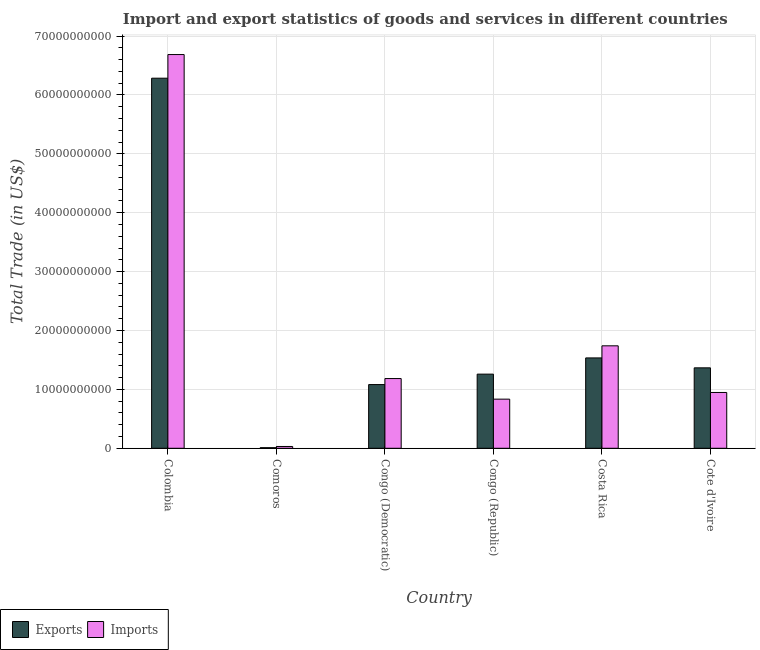How many groups of bars are there?
Offer a very short reply. 6. Are the number of bars per tick equal to the number of legend labels?
Provide a short and direct response. Yes. Are the number of bars on each tick of the X-axis equal?
Offer a very short reply. Yes. How many bars are there on the 6th tick from the right?
Your response must be concise. 2. What is the label of the 6th group of bars from the left?
Provide a succinct answer. Cote d'Ivoire. What is the imports of goods and services in Congo (Democratic)?
Your answer should be very brief. 1.18e+1. Across all countries, what is the maximum imports of goods and services?
Keep it short and to the point. 6.69e+1. Across all countries, what is the minimum imports of goods and services?
Your answer should be compact. 3.06e+08. In which country was the imports of goods and services minimum?
Your answer should be compact. Comoros. What is the total export of goods and services in the graph?
Keep it short and to the point. 1.15e+11. What is the difference between the imports of goods and services in Congo (Republic) and that in Cote d'Ivoire?
Your answer should be compact. -1.13e+09. What is the difference between the imports of goods and services in Congo (Republic) and the export of goods and services in Costa Rica?
Provide a short and direct response. -7.00e+09. What is the average export of goods and services per country?
Give a very brief answer. 1.92e+1. What is the difference between the export of goods and services and imports of goods and services in Cote d'Ivoire?
Keep it short and to the point. 4.18e+09. What is the ratio of the export of goods and services in Congo (Democratic) to that in Costa Rica?
Ensure brevity in your answer.  0.7. What is the difference between the highest and the second highest imports of goods and services?
Provide a succinct answer. 4.95e+1. What is the difference between the highest and the lowest imports of goods and services?
Offer a terse response. 6.66e+1. In how many countries, is the export of goods and services greater than the average export of goods and services taken over all countries?
Your answer should be very brief. 1. Is the sum of the export of goods and services in Congo (Republic) and Costa Rica greater than the maximum imports of goods and services across all countries?
Offer a terse response. No. What does the 2nd bar from the left in Cote d'Ivoire represents?
Provide a short and direct response. Imports. What does the 1st bar from the right in Congo (Republic) represents?
Give a very brief answer. Imports. How many bars are there?
Provide a short and direct response. 12. Are all the bars in the graph horizontal?
Ensure brevity in your answer.  No. How many countries are there in the graph?
Offer a terse response. 6. What is the difference between two consecutive major ticks on the Y-axis?
Offer a very short reply. 1.00e+1. What is the title of the graph?
Make the answer very short. Import and export statistics of goods and services in different countries. What is the label or title of the Y-axis?
Keep it short and to the point. Total Trade (in US$). What is the Total Trade (in US$) in Exports in Colombia?
Your answer should be compact. 6.28e+1. What is the Total Trade (in US$) in Imports in Colombia?
Your answer should be very brief. 6.69e+1. What is the Total Trade (in US$) in Exports in Comoros?
Your answer should be very brief. 9.90e+07. What is the Total Trade (in US$) of Imports in Comoros?
Ensure brevity in your answer.  3.06e+08. What is the Total Trade (in US$) in Exports in Congo (Democratic)?
Your response must be concise. 1.08e+1. What is the Total Trade (in US$) in Imports in Congo (Democratic)?
Provide a succinct answer. 1.18e+1. What is the Total Trade (in US$) in Exports in Congo (Republic)?
Your response must be concise. 1.26e+1. What is the Total Trade (in US$) in Imports in Congo (Republic)?
Provide a succinct answer. 8.34e+09. What is the Total Trade (in US$) in Exports in Costa Rica?
Offer a very short reply. 1.53e+1. What is the Total Trade (in US$) of Imports in Costa Rica?
Offer a terse response. 1.74e+1. What is the Total Trade (in US$) in Exports in Cote d'Ivoire?
Provide a succinct answer. 1.37e+1. What is the Total Trade (in US$) of Imports in Cote d'Ivoire?
Make the answer very short. 9.48e+09. Across all countries, what is the maximum Total Trade (in US$) in Exports?
Your answer should be compact. 6.28e+1. Across all countries, what is the maximum Total Trade (in US$) in Imports?
Provide a succinct answer. 6.69e+1. Across all countries, what is the minimum Total Trade (in US$) of Exports?
Offer a very short reply. 9.90e+07. Across all countries, what is the minimum Total Trade (in US$) in Imports?
Keep it short and to the point. 3.06e+08. What is the total Total Trade (in US$) of Exports in the graph?
Provide a succinct answer. 1.15e+11. What is the total Total Trade (in US$) in Imports in the graph?
Offer a very short reply. 1.14e+11. What is the difference between the Total Trade (in US$) in Exports in Colombia and that in Comoros?
Give a very brief answer. 6.27e+1. What is the difference between the Total Trade (in US$) in Imports in Colombia and that in Comoros?
Ensure brevity in your answer.  6.66e+1. What is the difference between the Total Trade (in US$) of Exports in Colombia and that in Congo (Democratic)?
Offer a very short reply. 5.20e+1. What is the difference between the Total Trade (in US$) of Imports in Colombia and that in Congo (Democratic)?
Offer a terse response. 5.50e+1. What is the difference between the Total Trade (in US$) in Exports in Colombia and that in Congo (Republic)?
Your response must be concise. 5.03e+1. What is the difference between the Total Trade (in US$) of Imports in Colombia and that in Congo (Republic)?
Provide a succinct answer. 5.85e+1. What is the difference between the Total Trade (in US$) in Exports in Colombia and that in Costa Rica?
Your answer should be very brief. 4.75e+1. What is the difference between the Total Trade (in US$) in Imports in Colombia and that in Costa Rica?
Provide a succinct answer. 4.95e+1. What is the difference between the Total Trade (in US$) of Exports in Colombia and that in Cote d'Ivoire?
Offer a very short reply. 4.92e+1. What is the difference between the Total Trade (in US$) of Imports in Colombia and that in Cote d'Ivoire?
Ensure brevity in your answer.  5.74e+1. What is the difference between the Total Trade (in US$) of Exports in Comoros and that in Congo (Democratic)?
Your response must be concise. -1.07e+1. What is the difference between the Total Trade (in US$) in Imports in Comoros and that in Congo (Democratic)?
Ensure brevity in your answer.  -1.15e+1. What is the difference between the Total Trade (in US$) of Exports in Comoros and that in Congo (Republic)?
Your response must be concise. -1.25e+1. What is the difference between the Total Trade (in US$) in Imports in Comoros and that in Congo (Republic)?
Your response must be concise. -8.04e+09. What is the difference between the Total Trade (in US$) of Exports in Comoros and that in Costa Rica?
Provide a succinct answer. -1.52e+1. What is the difference between the Total Trade (in US$) in Imports in Comoros and that in Costa Rica?
Make the answer very short. -1.71e+1. What is the difference between the Total Trade (in US$) in Exports in Comoros and that in Cote d'Ivoire?
Your response must be concise. -1.36e+1. What is the difference between the Total Trade (in US$) in Imports in Comoros and that in Cote d'Ivoire?
Your response must be concise. -9.17e+09. What is the difference between the Total Trade (in US$) in Exports in Congo (Democratic) and that in Congo (Republic)?
Keep it short and to the point. -1.77e+09. What is the difference between the Total Trade (in US$) of Imports in Congo (Democratic) and that in Congo (Republic)?
Make the answer very short. 3.50e+09. What is the difference between the Total Trade (in US$) of Exports in Congo (Democratic) and that in Costa Rica?
Provide a short and direct response. -4.53e+09. What is the difference between the Total Trade (in US$) of Imports in Congo (Democratic) and that in Costa Rica?
Give a very brief answer. -5.56e+09. What is the difference between the Total Trade (in US$) of Exports in Congo (Democratic) and that in Cote d'Ivoire?
Your answer should be compact. -2.84e+09. What is the difference between the Total Trade (in US$) in Imports in Congo (Democratic) and that in Cote d'Ivoire?
Offer a very short reply. 2.36e+09. What is the difference between the Total Trade (in US$) in Exports in Congo (Republic) and that in Costa Rica?
Ensure brevity in your answer.  -2.75e+09. What is the difference between the Total Trade (in US$) of Imports in Congo (Republic) and that in Costa Rica?
Ensure brevity in your answer.  -9.06e+09. What is the difference between the Total Trade (in US$) of Exports in Congo (Republic) and that in Cote d'Ivoire?
Offer a very short reply. -1.07e+09. What is the difference between the Total Trade (in US$) of Imports in Congo (Republic) and that in Cote d'Ivoire?
Give a very brief answer. -1.13e+09. What is the difference between the Total Trade (in US$) in Exports in Costa Rica and that in Cote d'Ivoire?
Offer a very short reply. 1.68e+09. What is the difference between the Total Trade (in US$) of Imports in Costa Rica and that in Cote d'Ivoire?
Give a very brief answer. 7.92e+09. What is the difference between the Total Trade (in US$) in Exports in Colombia and the Total Trade (in US$) in Imports in Comoros?
Provide a succinct answer. 6.25e+1. What is the difference between the Total Trade (in US$) in Exports in Colombia and the Total Trade (in US$) in Imports in Congo (Democratic)?
Give a very brief answer. 5.10e+1. What is the difference between the Total Trade (in US$) in Exports in Colombia and the Total Trade (in US$) in Imports in Congo (Republic)?
Offer a very short reply. 5.45e+1. What is the difference between the Total Trade (in US$) of Exports in Colombia and the Total Trade (in US$) of Imports in Costa Rica?
Offer a very short reply. 4.54e+1. What is the difference between the Total Trade (in US$) in Exports in Colombia and the Total Trade (in US$) in Imports in Cote d'Ivoire?
Your answer should be compact. 5.34e+1. What is the difference between the Total Trade (in US$) of Exports in Comoros and the Total Trade (in US$) of Imports in Congo (Democratic)?
Make the answer very short. -1.17e+1. What is the difference between the Total Trade (in US$) in Exports in Comoros and the Total Trade (in US$) in Imports in Congo (Republic)?
Offer a very short reply. -8.24e+09. What is the difference between the Total Trade (in US$) of Exports in Comoros and the Total Trade (in US$) of Imports in Costa Rica?
Keep it short and to the point. -1.73e+1. What is the difference between the Total Trade (in US$) in Exports in Comoros and the Total Trade (in US$) in Imports in Cote d'Ivoire?
Offer a terse response. -9.38e+09. What is the difference between the Total Trade (in US$) in Exports in Congo (Democratic) and the Total Trade (in US$) in Imports in Congo (Republic)?
Your answer should be very brief. 2.47e+09. What is the difference between the Total Trade (in US$) of Exports in Congo (Democratic) and the Total Trade (in US$) of Imports in Costa Rica?
Offer a terse response. -6.58e+09. What is the difference between the Total Trade (in US$) of Exports in Congo (Democratic) and the Total Trade (in US$) of Imports in Cote d'Ivoire?
Make the answer very short. 1.34e+09. What is the difference between the Total Trade (in US$) in Exports in Congo (Republic) and the Total Trade (in US$) in Imports in Costa Rica?
Your response must be concise. -4.81e+09. What is the difference between the Total Trade (in US$) of Exports in Congo (Republic) and the Total Trade (in US$) of Imports in Cote d'Ivoire?
Provide a short and direct response. 3.11e+09. What is the difference between the Total Trade (in US$) in Exports in Costa Rica and the Total Trade (in US$) in Imports in Cote d'Ivoire?
Provide a short and direct response. 5.87e+09. What is the average Total Trade (in US$) of Exports per country?
Give a very brief answer. 1.92e+1. What is the average Total Trade (in US$) in Imports per country?
Offer a very short reply. 1.90e+1. What is the difference between the Total Trade (in US$) of Exports and Total Trade (in US$) of Imports in Colombia?
Your response must be concise. -4.01e+09. What is the difference between the Total Trade (in US$) of Exports and Total Trade (in US$) of Imports in Comoros?
Provide a short and direct response. -2.07e+08. What is the difference between the Total Trade (in US$) of Exports and Total Trade (in US$) of Imports in Congo (Democratic)?
Give a very brief answer. -1.02e+09. What is the difference between the Total Trade (in US$) in Exports and Total Trade (in US$) in Imports in Congo (Republic)?
Your answer should be very brief. 4.25e+09. What is the difference between the Total Trade (in US$) of Exports and Total Trade (in US$) of Imports in Costa Rica?
Offer a very short reply. -2.05e+09. What is the difference between the Total Trade (in US$) in Exports and Total Trade (in US$) in Imports in Cote d'Ivoire?
Your answer should be very brief. 4.18e+09. What is the ratio of the Total Trade (in US$) in Exports in Colombia to that in Comoros?
Provide a succinct answer. 635.07. What is the ratio of the Total Trade (in US$) in Imports in Colombia to that in Comoros?
Your answer should be compact. 218.31. What is the ratio of the Total Trade (in US$) in Exports in Colombia to that in Congo (Democratic)?
Your response must be concise. 5.81. What is the ratio of the Total Trade (in US$) of Imports in Colombia to that in Congo (Democratic)?
Your answer should be very brief. 5.65. What is the ratio of the Total Trade (in US$) of Exports in Colombia to that in Congo (Republic)?
Give a very brief answer. 4.99. What is the ratio of the Total Trade (in US$) of Imports in Colombia to that in Congo (Republic)?
Keep it short and to the point. 8.01. What is the ratio of the Total Trade (in US$) of Exports in Colombia to that in Costa Rica?
Give a very brief answer. 4.1. What is the ratio of the Total Trade (in US$) of Imports in Colombia to that in Costa Rica?
Give a very brief answer. 3.84. What is the ratio of the Total Trade (in US$) of Exports in Colombia to that in Cote d'Ivoire?
Offer a very short reply. 4.6. What is the ratio of the Total Trade (in US$) of Imports in Colombia to that in Cote d'Ivoire?
Keep it short and to the point. 7.06. What is the ratio of the Total Trade (in US$) in Exports in Comoros to that in Congo (Democratic)?
Your response must be concise. 0.01. What is the ratio of the Total Trade (in US$) of Imports in Comoros to that in Congo (Democratic)?
Your response must be concise. 0.03. What is the ratio of the Total Trade (in US$) of Exports in Comoros to that in Congo (Republic)?
Give a very brief answer. 0.01. What is the ratio of the Total Trade (in US$) of Imports in Comoros to that in Congo (Republic)?
Give a very brief answer. 0.04. What is the ratio of the Total Trade (in US$) of Exports in Comoros to that in Costa Rica?
Offer a very short reply. 0.01. What is the ratio of the Total Trade (in US$) of Imports in Comoros to that in Costa Rica?
Provide a short and direct response. 0.02. What is the ratio of the Total Trade (in US$) of Exports in Comoros to that in Cote d'Ivoire?
Offer a terse response. 0.01. What is the ratio of the Total Trade (in US$) in Imports in Comoros to that in Cote d'Ivoire?
Provide a succinct answer. 0.03. What is the ratio of the Total Trade (in US$) of Exports in Congo (Democratic) to that in Congo (Republic)?
Make the answer very short. 0.86. What is the ratio of the Total Trade (in US$) in Imports in Congo (Democratic) to that in Congo (Republic)?
Ensure brevity in your answer.  1.42. What is the ratio of the Total Trade (in US$) in Exports in Congo (Democratic) to that in Costa Rica?
Your answer should be compact. 0.7. What is the ratio of the Total Trade (in US$) of Imports in Congo (Democratic) to that in Costa Rica?
Make the answer very short. 0.68. What is the ratio of the Total Trade (in US$) of Exports in Congo (Democratic) to that in Cote d'Ivoire?
Offer a terse response. 0.79. What is the ratio of the Total Trade (in US$) of Imports in Congo (Democratic) to that in Cote d'Ivoire?
Provide a succinct answer. 1.25. What is the ratio of the Total Trade (in US$) of Exports in Congo (Republic) to that in Costa Rica?
Offer a very short reply. 0.82. What is the ratio of the Total Trade (in US$) in Imports in Congo (Republic) to that in Costa Rica?
Provide a succinct answer. 0.48. What is the ratio of the Total Trade (in US$) in Exports in Congo (Republic) to that in Cote d'Ivoire?
Offer a very short reply. 0.92. What is the ratio of the Total Trade (in US$) of Imports in Congo (Republic) to that in Cote d'Ivoire?
Offer a terse response. 0.88. What is the ratio of the Total Trade (in US$) in Exports in Costa Rica to that in Cote d'Ivoire?
Offer a terse response. 1.12. What is the ratio of the Total Trade (in US$) in Imports in Costa Rica to that in Cote d'Ivoire?
Give a very brief answer. 1.84. What is the difference between the highest and the second highest Total Trade (in US$) of Exports?
Ensure brevity in your answer.  4.75e+1. What is the difference between the highest and the second highest Total Trade (in US$) in Imports?
Provide a short and direct response. 4.95e+1. What is the difference between the highest and the lowest Total Trade (in US$) in Exports?
Provide a short and direct response. 6.27e+1. What is the difference between the highest and the lowest Total Trade (in US$) in Imports?
Make the answer very short. 6.66e+1. 